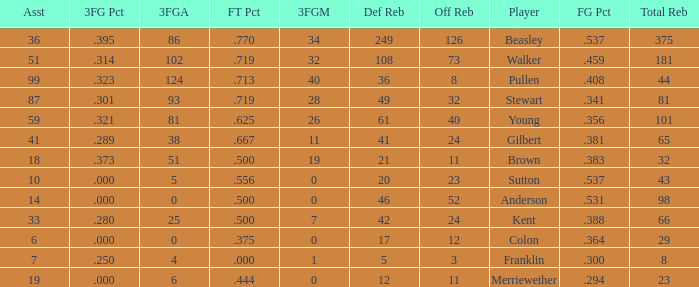Would you be able to parse every entry in this table? {'header': ['Asst', '3FG Pct', '3FGA', 'FT Pct', '3FGM', 'Def Reb', 'Off Reb', 'Player', 'FG Pct', 'Total Reb'], 'rows': [['36', '.395', '86', '.770', '34', '249', '126', 'Beasley', '.537', '375'], ['51', '.314', '102', '.719', '32', '108', '73', 'Walker', '.459', '181'], ['99', '.323', '124', '.713', '40', '36', '8', 'Pullen', '.408', '44'], ['87', '.301', '93', '.719', '28', '49', '32', 'Stewart', '.341', '81'], ['59', '.321', '81', '.625', '26', '61', '40', 'Young', '.356', '101'], ['41', '.289', '38', '.667', '11', '41', '24', 'Gilbert', '.381', '65'], ['18', '.373', '51', '.500', '19', '21', '11', 'Brown', '.383', '32'], ['10', '.000', '5', '.556', '0', '20', '23', 'Sutton', '.537', '43'], ['14', '.000', '0', '.500', '0', '46', '52', 'Anderson', '.531', '98'], ['33', '.280', '25', '.500', '7', '42', '24', 'Kent', '.388', '66'], ['6', '.000', '0', '.375', '0', '17', '12', 'Colon', '.364', '29'], ['7', '.250', '4', '.000', '1', '5', '3', 'Franklin', '.300', '8'], ['19', '.000', '6', '.444', '0', '12', '11', 'Merriewether', '.294', '23']]} What is the cumulative number of offensive rebounds for players who attempted over 124 3-pointers? 0.0. 